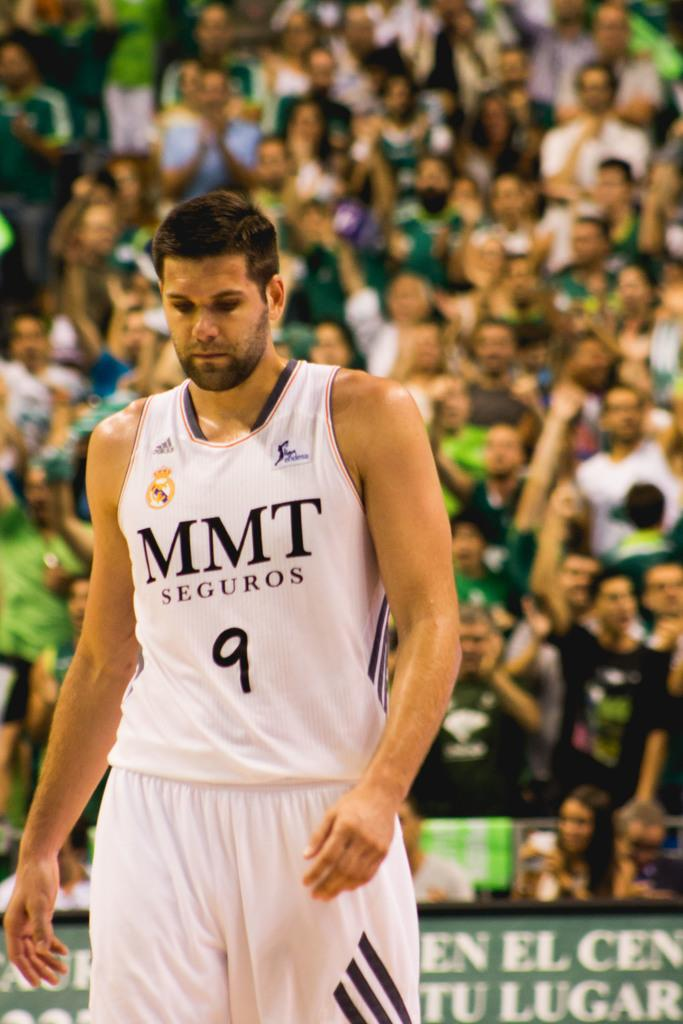<image>
Share a concise interpretation of the image provided. A player from MMT Seguros walks on the court. 